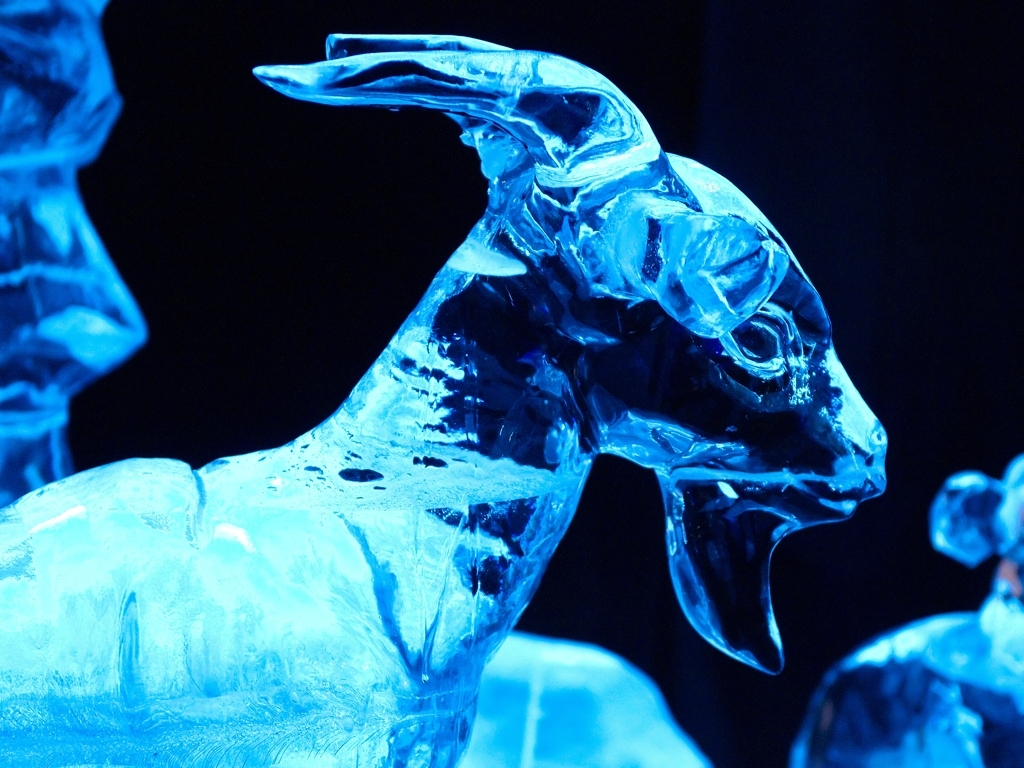What kind of event might this ice sculpture be displayed at? Ice sculptures of this complexity and beauty are often featured at winter festivals, ice carving competitions, or special events like corporate functions and weddings. The ambient lighting suggests this sculpture may be part of an evening event, where the dramatic illumination can enhance its visual impact. 